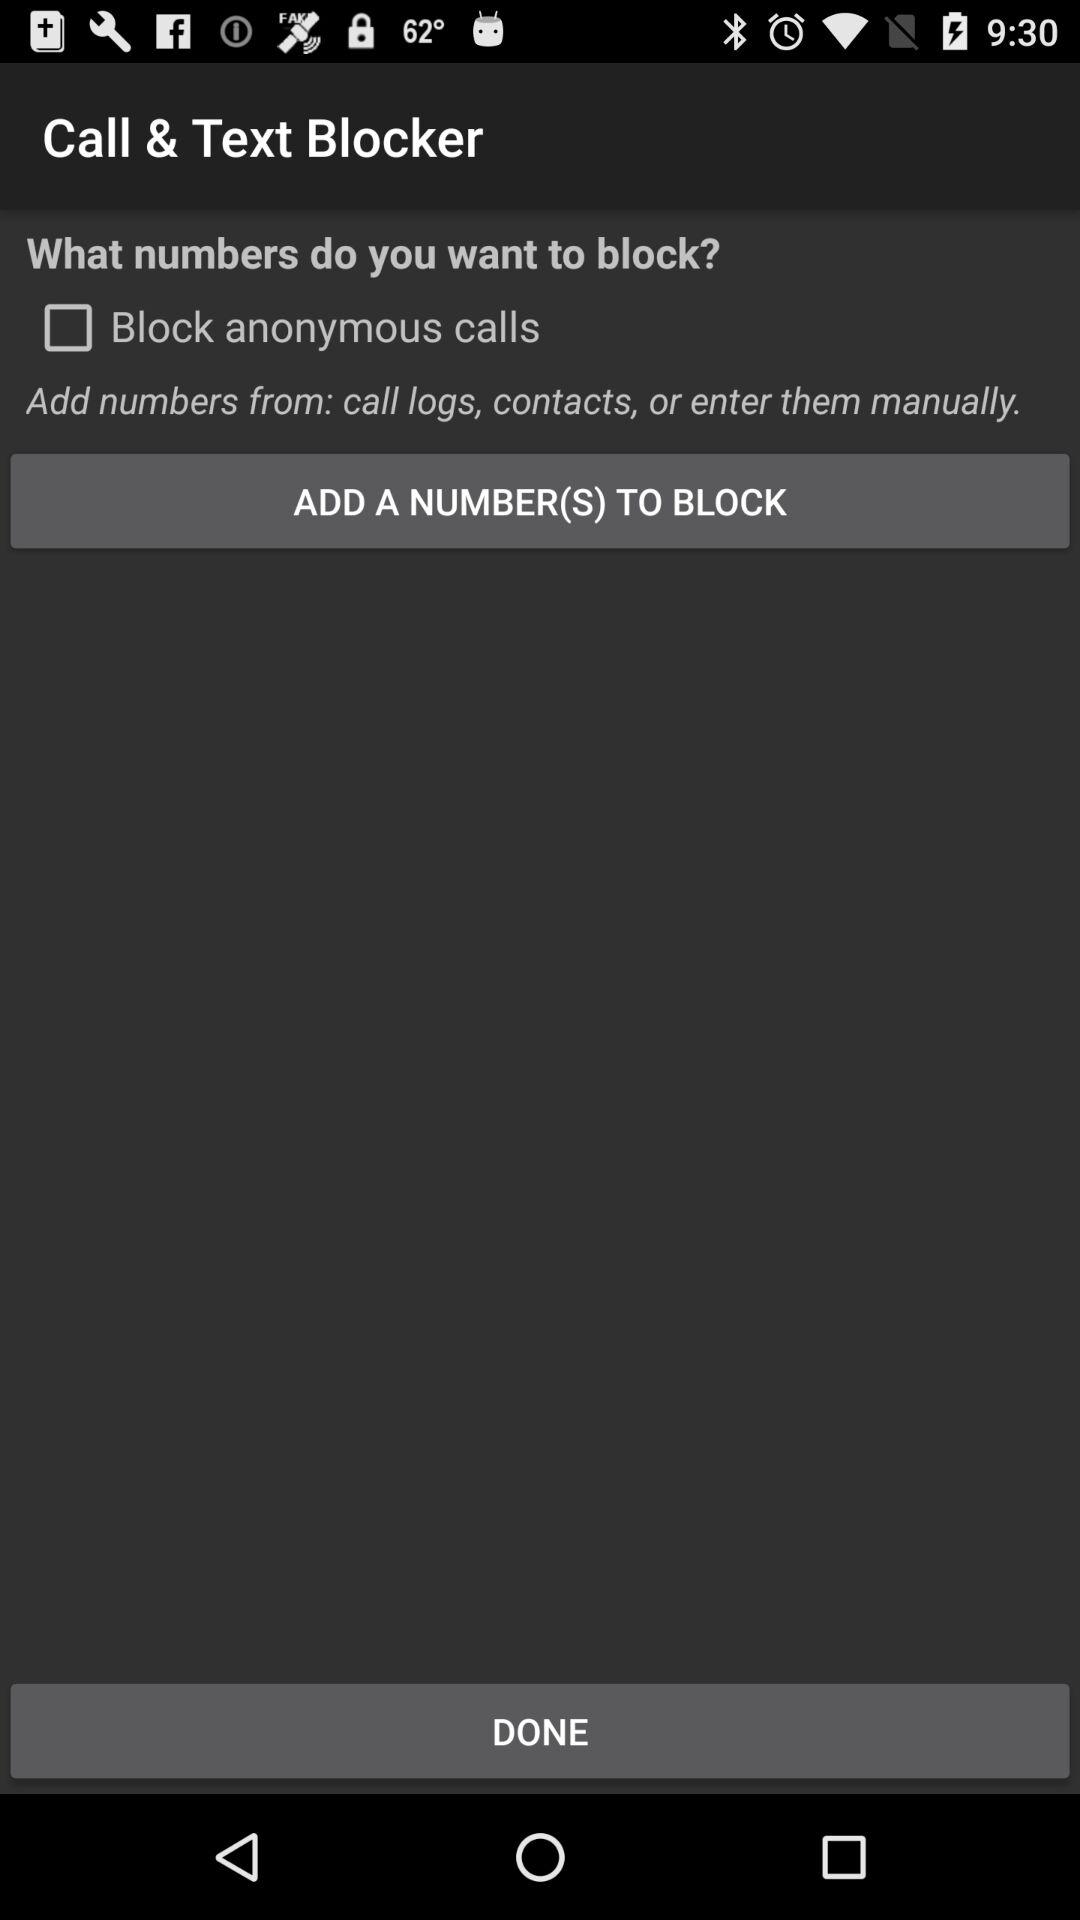Who is this application powered by?
When the provided information is insufficient, respond with <no answer>. <no answer> 